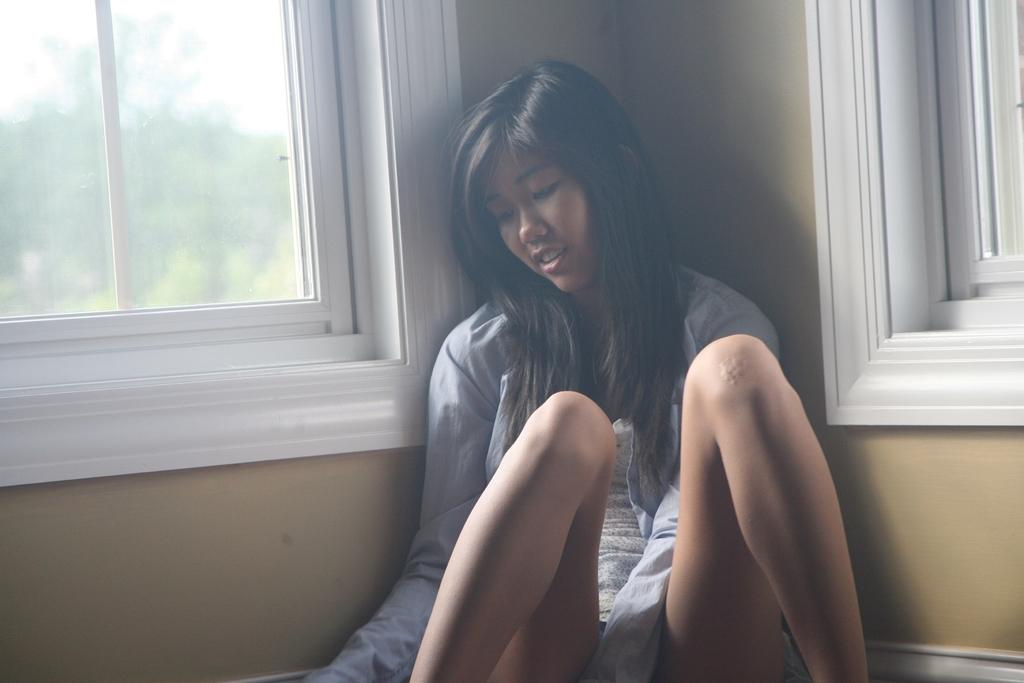Who is the main subject in the image? There is a woman in the image. What is the woman wearing? The woman is wearing a white t-shirt. Where is the woman located in the image? The woman is visible in front of a window. What else can be seen in the image? There is a wall visible in the image, and there is a girl in the image as well. How is the girl positioned in the image? The backside of the girl is visible, and her mouth is open. What is the temperature of the heat source in the image? There is no heat source present in the image. Does the existence of the girl in the image prove the existence of extraterrestrial life? The presence of the girl in the image does not prove the existence of extraterrestrial life, as she is a human being. What is the size of the girl in the image compared to the size of the window? The size of the girl in the image cannot be determined in comparison to the size of the window without additional information. 